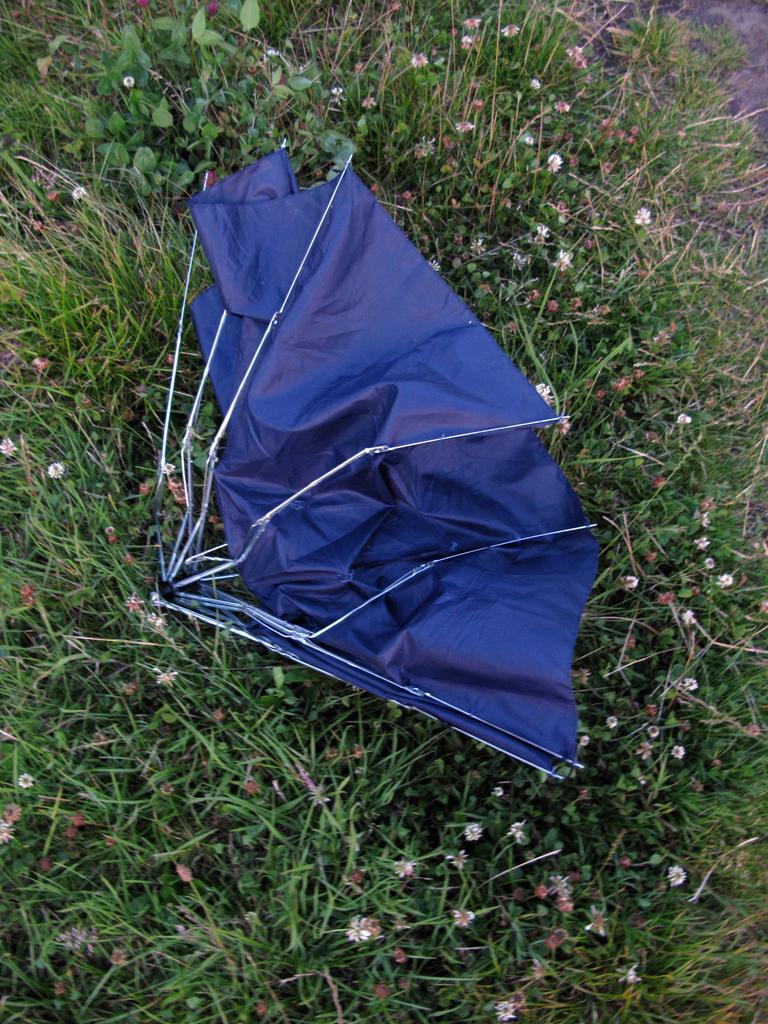How would you summarize this image in a sentence or two? In this image we can see an umbrella. And we can see the plants with flowers. 